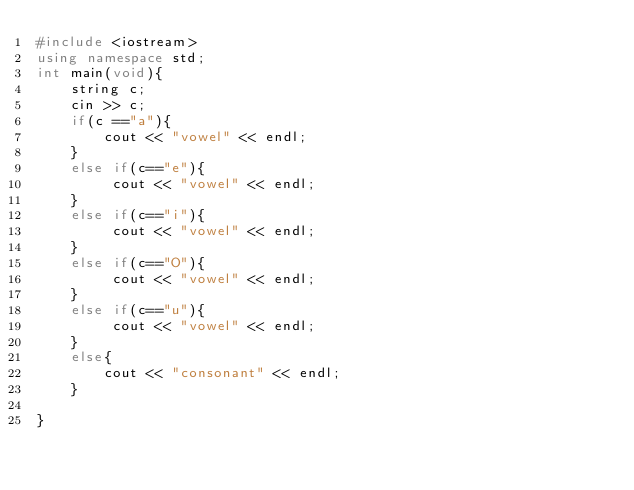<code> <loc_0><loc_0><loc_500><loc_500><_C++_>#include <iostream>
using namespace std;
int main(void){
    string c;
    cin >> c;
    if(c =="a"){
        cout << "vowel" << endl;
    }
    else if(c=="e"){
         cout << "vowel" << endl;
    }
    else if(c=="i"){
         cout << "vowel" << endl;
    }
    else if(c=="O"){
         cout << "vowel" << endl;
    }
    else if(c=="u"){
         cout << "vowel" << endl;
    }
    else{
        cout << "consonant" << endl;
    }
    
}
</code> 